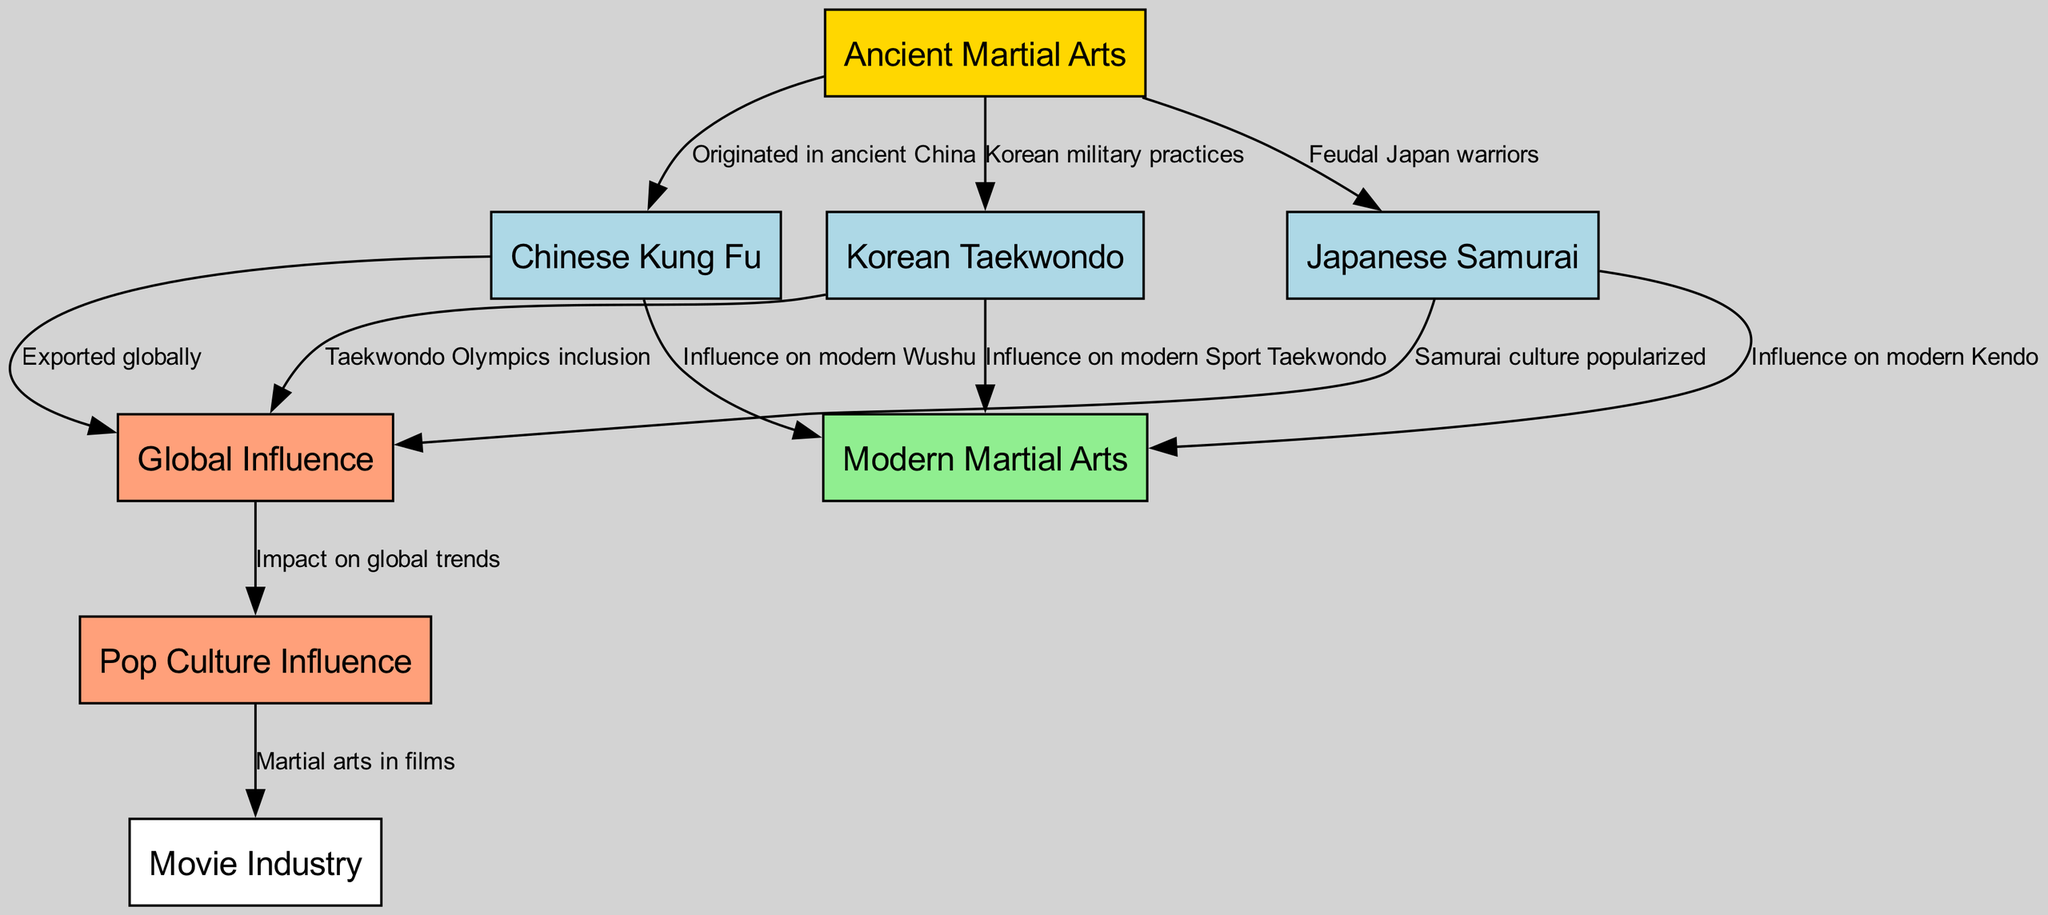What is the oldest martial art mentioned in the diagram? The diagram starts with "Ancient Martial Arts" as the first node, indicating it is the oldest martial art represented. There are no nodes connecting to any older martial arts, affirming it as the oldest.
Answer: Ancient Martial Arts How many martial arts are specifically influenced by Asian cultures? By examining the edges from the "Ancient Martial Arts" node, we see there are three direct connections to "Chinese Kung Fu," "Japanese Samurai," and "Korean Taekwondo," indicating that these three martial arts are influenced by Asian cultures.
Answer: 3 What martial art influences modern Wushu? Looking at the edges, we find that "Chinese Kung Fu" directly connects to "Modern Martial Arts" with the label indicating its influence on contemporary Wushu practices.
Answer: Chinese Kung Fu What cultural aspect popularized Samurai culture globally? From the diagram, "Samurai culture popularized" is linked to the edge connecting the "Japanese Samurai" node to the "Global Influence" node, indicating the cultural impact that spread Samurai traditions worldwide.
Answer: Samurai culture popularized Which martial art is connected to the Olympics in the diagram? The edge from "Korean Taekwondo" directly connects to "Global Influence" with a label that states "Taekwondo Olympics inclusion," clearly indicating the martial art associated with the Olympics.
Answer: Korean Taekwondo How does Pop Culture influence martial arts? The edge indicates that "Global Influence" connects to "Pop Culture Influence," with the label stating "Impact on global trends," showcasing how widespread cultural trends affect martial arts perception and popularity.
Answer: Impact on global trends Which node represents the influence of movies on martial arts? The diagram shows an edge between "Pop Culture Influence" and "Movie Industry," indicating that the movie industry is a representation of how martial arts is depicted and influenced by cinematic portrayals.
Answer: Movie Industry How many nodes represent modern martial arts? Analyzing the diagram, we identify one node specifically labeled "Modern Martial Arts," suggesting that it summarizes contemporary styles derived from the historical martial arts shown earlier.
Answer: 1 What is the relationship between Korean military practices and modern Taekwondo? The diagram shows a direct connection from "Korean military practices" to "Korean Taekwondo," indicating that modern Taekwondo has its roots in historical military practices of Korea.
Answer: Korean military practices 